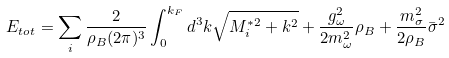Convert formula to latex. <formula><loc_0><loc_0><loc_500><loc_500>E _ { t o t } = \sum _ { i } \frac { 2 } { \rho _ { B } ( 2 \pi ) ^ { 3 } } \int _ { 0 } ^ { k _ { F } } d ^ { 3 } k \sqrt { M _ { i } ^ { * 2 } + k ^ { 2 } } + \frac { g _ { \omega } ^ { 2 } } { 2 m _ { \omega } ^ { 2 } } \rho _ { B } + \frac { m _ { \sigma } ^ { 2 } } { 2 \rho _ { B } } \bar { \sigma } ^ { 2 }</formula> 